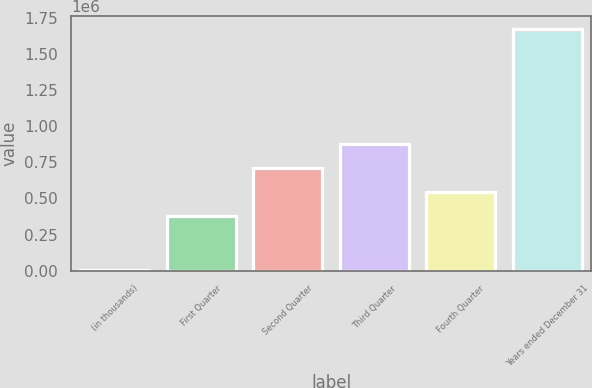Convert chart. <chart><loc_0><loc_0><loc_500><loc_500><bar_chart><fcel>(in thousands)<fcel>First Quarter<fcel>Second Quarter<fcel>Third Quarter<fcel>Fourth Quarter<fcel>Years ended December 31<nl><fcel>2017<fcel>375247<fcel>709635<fcel>876829<fcel>542441<fcel>1.67396e+06<nl></chart> 